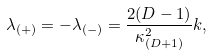<formula> <loc_0><loc_0><loc_500><loc_500>\lambda _ { ( + ) } = - \lambda _ { ( - ) } = \frac { 2 ( D - 1 ) } { \kappa _ { ( D + 1 ) } ^ { 2 } } k ,</formula> 